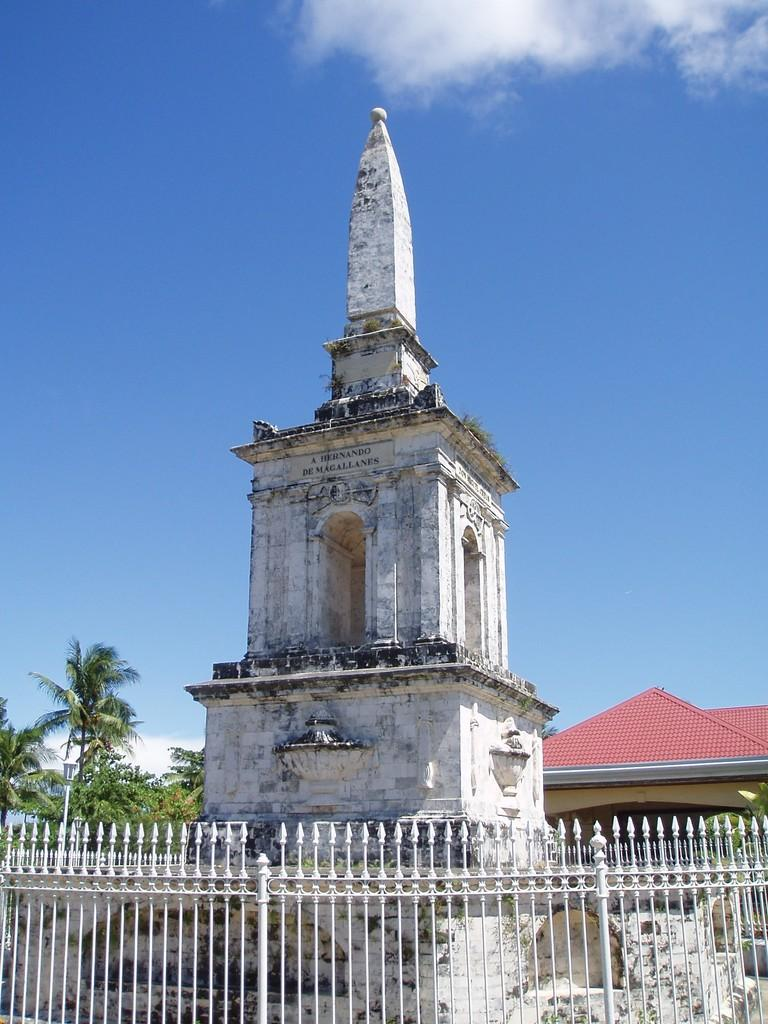What is located at the bottom of the image? There is fencing at the bottom of the image. What can be seen in the background of the image? There are buildings and trees in the background of the image. What is visible at the top of the image? The sky is visible at the top of the image. What can be observed in the sky? Clouds are present in the sky. What type of fruit can be seen hanging from the fencing in the image? There is no fruit hanging from the fencing in the image. 